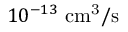Convert formula to latex. <formula><loc_0><loc_0><loc_500><loc_500>1 0 ^ { - 1 3 } c m ^ { 3 } / s</formula> 